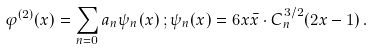Convert formula to latex. <formula><loc_0><loc_0><loc_500><loc_500>\varphi ^ { ( 2 ) } ( x ) = \sum _ { n = 0 } a _ { n } \psi _ { n } ( x ) \, ; \psi _ { n } ( x ) = 6 x \bar { x } \cdot C ^ { 3 / 2 } _ { n } ( 2 x - 1 ) \, .</formula> 